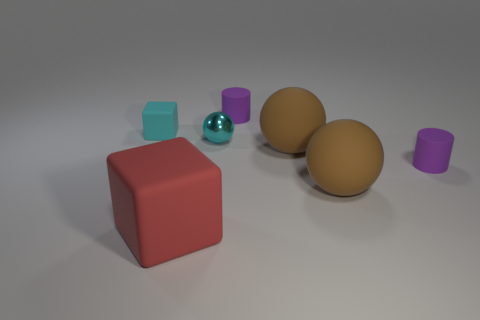Add 3 green cylinders. How many objects exist? 10 Subtract all cubes. How many objects are left? 5 Subtract 0 purple balls. How many objects are left? 7 Subtract all brown shiny cubes. Subtract all matte cylinders. How many objects are left? 5 Add 7 cyan shiny balls. How many cyan shiny balls are left? 8 Add 4 spheres. How many spheres exist? 7 